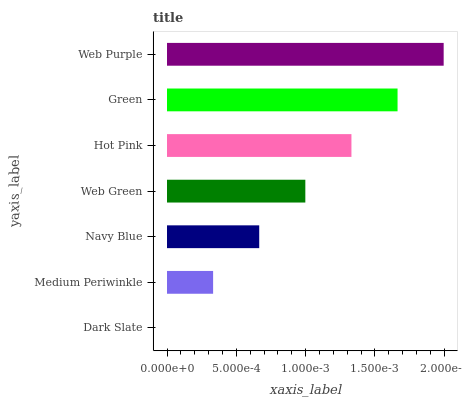Is Dark Slate the minimum?
Answer yes or no. Yes. Is Web Purple the maximum?
Answer yes or no. Yes. Is Medium Periwinkle the minimum?
Answer yes or no. No. Is Medium Periwinkle the maximum?
Answer yes or no. No. Is Medium Periwinkle greater than Dark Slate?
Answer yes or no. Yes. Is Dark Slate less than Medium Periwinkle?
Answer yes or no. Yes. Is Dark Slate greater than Medium Periwinkle?
Answer yes or no. No. Is Medium Periwinkle less than Dark Slate?
Answer yes or no. No. Is Web Green the high median?
Answer yes or no. Yes. Is Web Green the low median?
Answer yes or no. Yes. Is Hot Pink the high median?
Answer yes or no. No. Is Dark Slate the low median?
Answer yes or no. No. 